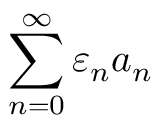Convert formula to latex. <formula><loc_0><loc_0><loc_500><loc_500>\sum _ { n = 0 } ^ { \infty } \varepsilon _ { n } a _ { n }</formula> 